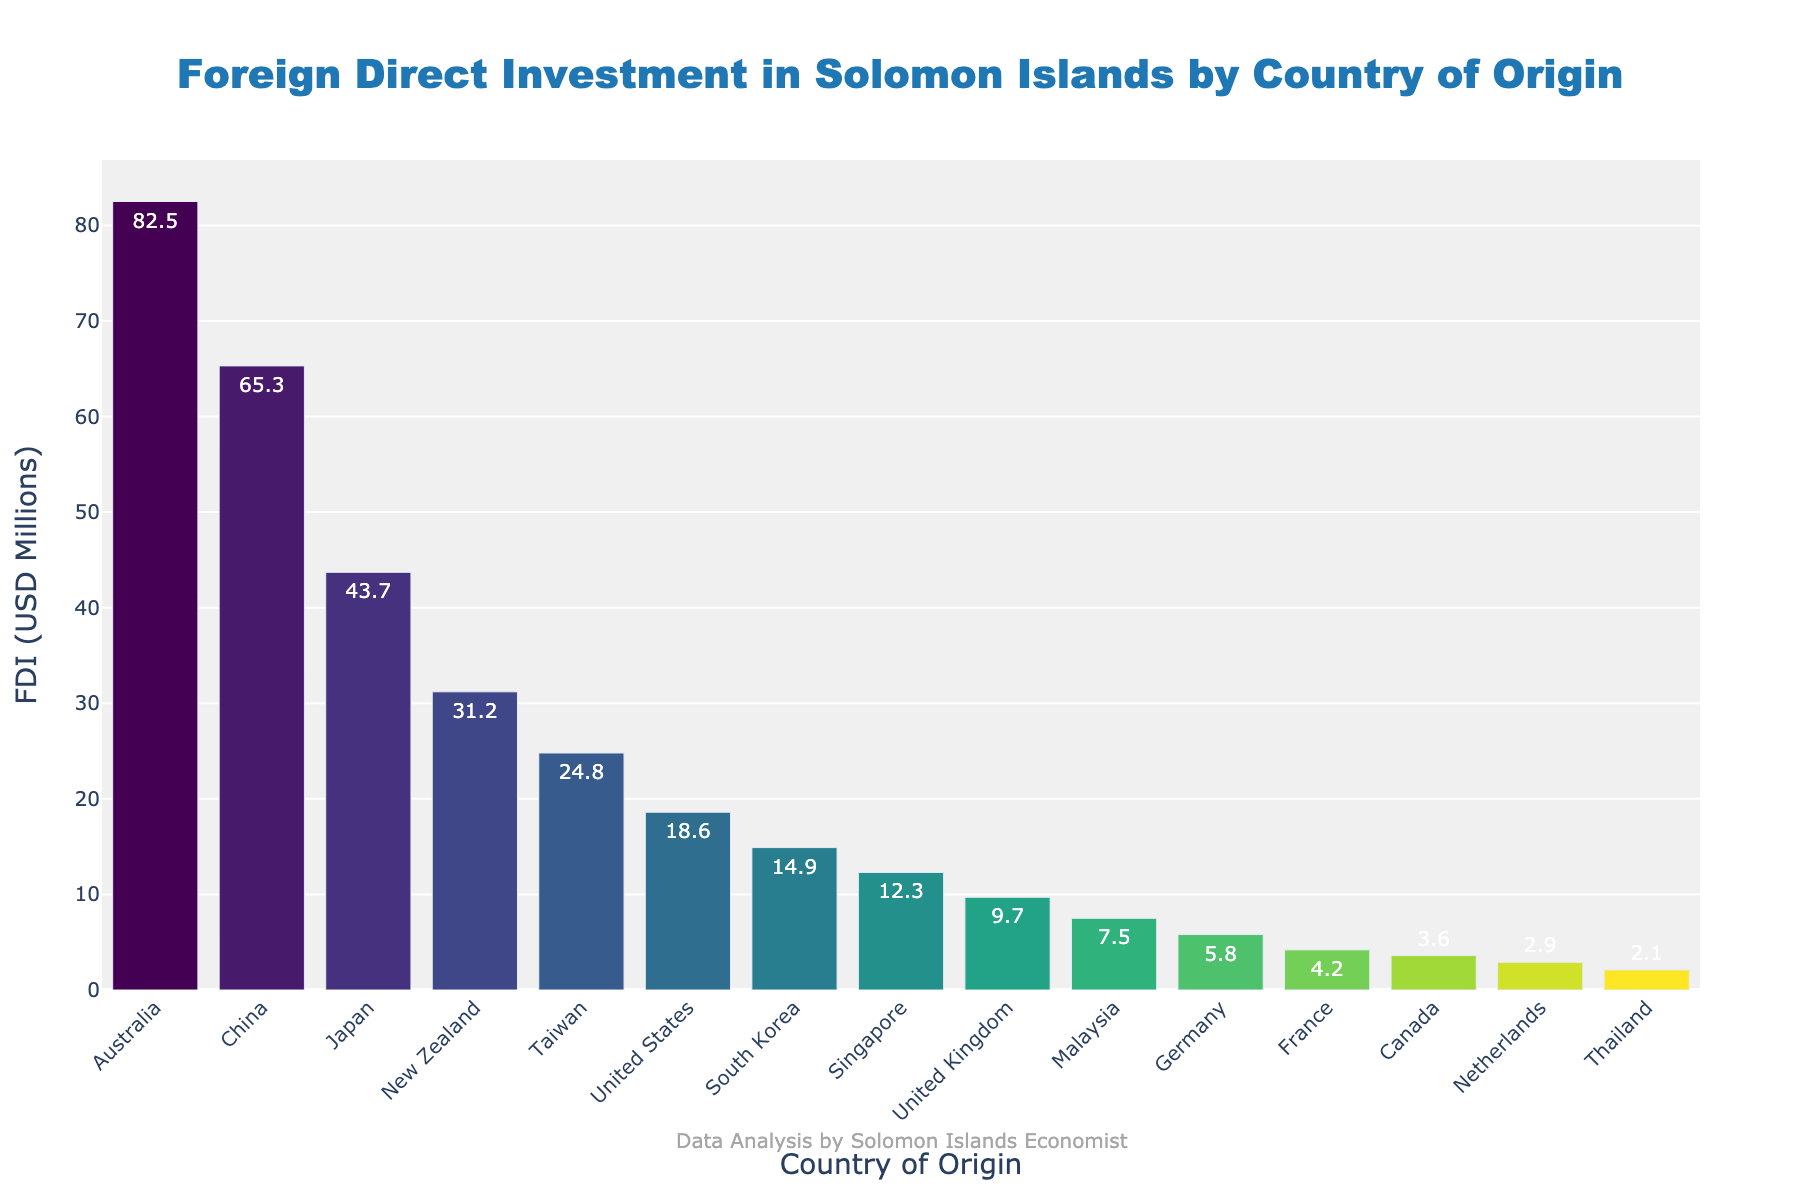Who is the largest foreign direct investor in Solomon Islands? The bar for Australia is the highest in the chart, indicating it is the largest investor.
Answer: Australia What is the total FDI from Australia and China? Refer to the bars' FDI values: Australia (82.5) and China (65.3). Sum them: 82.5 + 65.3 = 147.8
Answer: 147.8 Which country has a higher FDI, Japan or New Zealand? Compare the bars for both countries. Japan's FDI is 43.7, and New Zealand's is 31.2. Japan has a higher FDI.
Answer: Japan What is the difference in FDI between the United States and France? Refer to the bars' FDI values: United States (18.6) and France (4.2). The difference is 18.6 - 4.2 = 14.4
Answer: 14.4 What is the average FDI from the top 5 investing countries? Top 5 countries are Australia (82.5), China (65.3), Japan (43.7), New Zealand (31.2), and Taiwan (24.8). Sum them: 82.5 + 65.3 + 43.7 + 31.2 + 24.8 = 247.5. Divide by 5: 247.5 / 5 = 49.5
Answer: 49.5 Which country has the smallest FDI, and what is its value? The shortest bar represents Thailand with an FDI of 2.1.
Answer: Thailand, 2.1 What is the combined FDI from the United Kingdom and Germany? Refer to the bars' FDI values: United Kingdom (9.7) and Germany (5.8). Sum them: 9.7 + 5.8 = 15.5
Answer: 15.5 What is the median FDI value of all the countries? List all FDI values: [82.5, 65.3, 43.7, 31.2, 24.8, 18.6, 14.9, 12.3, 9.7, 7.5, 5.8, 4.2, 3.6, 2.9, 2.1]. The median is the middle value, which is 14.9.
Answer: 14.9 How does the FDI from Australia compare to the sum of FDI from Malaysia, Germany, France, and Canada? Sum the FDI from Malaysia (7.5), Germany (5.8), France (4.2), and Canada (3.6): 7.5 + 5.8 + 4.2 + 3.6 = 21.1. Australia's FDI is 82.5, which is greater.
Answer: Greater What is the FDI value of countries with blue bars and how many countries have blue bars? Since blue appears as the last color in the "Viridis" colorscale, the country with the smallest value, Thailand (2.1), has a blue bar. There is only 1 blue bar.
Answer: 2.1 and 1 